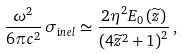Convert formula to latex. <formula><loc_0><loc_0><loc_500><loc_500>\frac { \omega ^ { 2 } } { 6 \pi c ^ { 2 } } \, \sigma _ { \mathrm i n e l } \simeq \frac { 2 \eta ^ { 2 } E _ { 0 } \left ( \widetilde { z } \right ) } { \left ( 4 \widetilde { z } ^ { 2 } + 1 \right ) ^ { 2 } } \, ,</formula> 